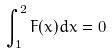Convert formula to latex. <formula><loc_0><loc_0><loc_500><loc_500>\int _ { 1 } ^ { 2 } F ( x ) d x = 0</formula> 